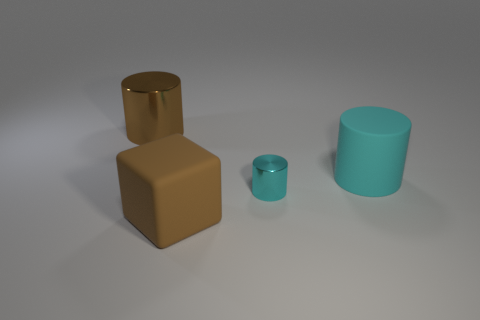Subtract all large cylinders. How many cylinders are left? 1 Subtract all gray balls. How many cyan cylinders are left? 2 Add 1 cubes. How many objects exist? 5 Subtract all cyan cylinders. How many cylinders are left? 1 Subtract 2 cylinders. How many cylinders are left? 1 Subtract all cylinders. How many objects are left? 1 Subtract all blue cylinders. Subtract all blue blocks. How many cylinders are left? 3 Add 2 shiny objects. How many shiny objects are left? 4 Add 2 green metallic blocks. How many green metallic blocks exist? 2 Subtract 0 cyan cubes. How many objects are left? 4 